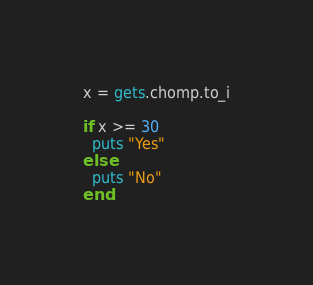Convert code to text. <code><loc_0><loc_0><loc_500><loc_500><_Ruby_>x = gets.chomp.to_i

if x >= 30
  puts "Yes"
else
  puts "No"
end
</code> 